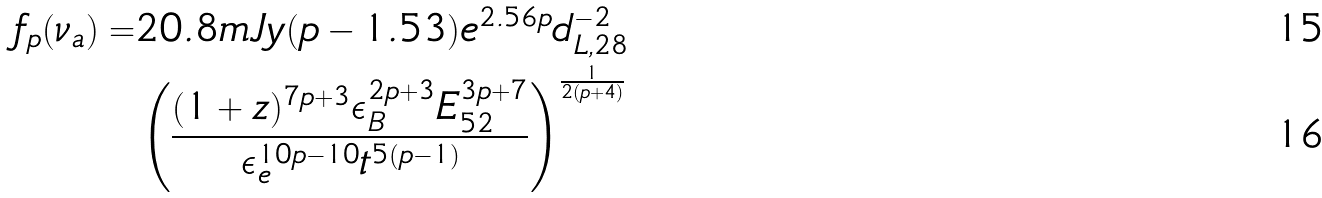Convert formula to latex. <formula><loc_0><loc_0><loc_500><loc_500>f _ { p } ( \nu _ { a } ) = & 2 0 . 8 m J y ( p - 1 . 5 3 ) e ^ { 2 . 5 6 p } d _ { L , 2 8 } ^ { - 2 } \\ & \left ( \frac { ( 1 + z ) ^ { 7 p + 3 } \epsilon _ { B } ^ { 2 p + 3 } E _ { 5 2 } ^ { 3 p + 7 } } { \epsilon _ { e } ^ { 1 0 p - 1 0 } t ^ { 5 ( p - 1 ) } } \right ) ^ { \frac { 1 } { 2 ( p + 4 ) } }</formula> 